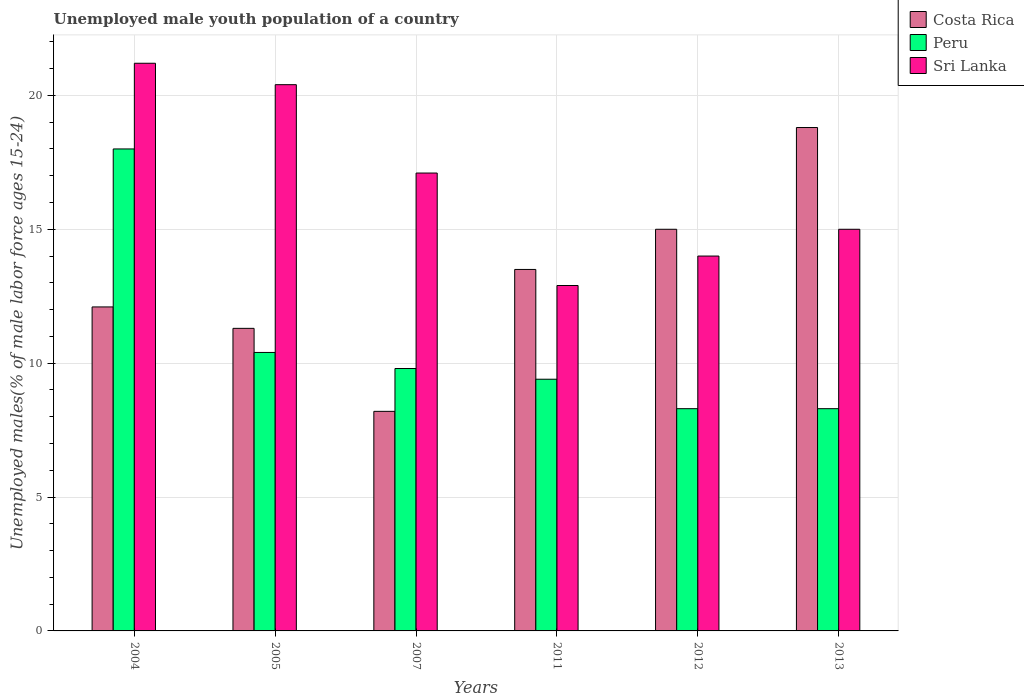How many different coloured bars are there?
Offer a very short reply. 3. How many groups of bars are there?
Your response must be concise. 6. Are the number of bars per tick equal to the number of legend labels?
Ensure brevity in your answer.  Yes. Are the number of bars on each tick of the X-axis equal?
Give a very brief answer. Yes. How many bars are there on the 1st tick from the left?
Your response must be concise. 3. In how many cases, is the number of bars for a given year not equal to the number of legend labels?
Provide a succinct answer. 0. Across all years, what is the maximum percentage of unemployed male youth population in Peru?
Ensure brevity in your answer.  18. Across all years, what is the minimum percentage of unemployed male youth population in Sri Lanka?
Your answer should be very brief. 12.9. What is the total percentage of unemployed male youth population in Costa Rica in the graph?
Offer a terse response. 78.9. What is the difference between the percentage of unemployed male youth population in Sri Lanka in 2007 and that in 2011?
Offer a terse response. 4.2. What is the difference between the percentage of unemployed male youth population in Costa Rica in 2011 and the percentage of unemployed male youth population in Sri Lanka in 2007?
Give a very brief answer. -3.6. What is the average percentage of unemployed male youth population in Peru per year?
Your response must be concise. 10.7. In the year 2013, what is the difference between the percentage of unemployed male youth population in Peru and percentage of unemployed male youth population in Costa Rica?
Your answer should be very brief. -10.5. In how many years, is the percentage of unemployed male youth population in Costa Rica greater than 1 %?
Provide a short and direct response. 6. What is the ratio of the percentage of unemployed male youth population in Sri Lanka in 2011 to that in 2013?
Offer a terse response. 0.86. Is the difference between the percentage of unemployed male youth population in Peru in 2011 and 2013 greater than the difference between the percentage of unemployed male youth population in Costa Rica in 2011 and 2013?
Provide a short and direct response. Yes. What is the difference between the highest and the second highest percentage of unemployed male youth population in Costa Rica?
Your answer should be compact. 3.8. What is the difference between the highest and the lowest percentage of unemployed male youth population in Sri Lanka?
Your response must be concise. 8.3. Is the sum of the percentage of unemployed male youth population in Sri Lanka in 2011 and 2013 greater than the maximum percentage of unemployed male youth population in Costa Rica across all years?
Provide a succinct answer. Yes. What does the 3rd bar from the right in 2005 represents?
Your answer should be very brief. Costa Rica. Is it the case that in every year, the sum of the percentage of unemployed male youth population in Costa Rica and percentage of unemployed male youth population in Sri Lanka is greater than the percentage of unemployed male youth population in Peru?
Provide a short and direct response. Yes. How many bars are there?
Provide a short and direct response. 18. Does the graph contain grids?
Ensure brevity in your answer.  Yes. What is the title of the graph?
Your answer should be compact. Unemployed male youth population of a country. Does "Central Europe" appear as one of the legend labels in the graph?
Ensure brevity in your answer.  No. What is the label or title of the Y-axis?
Your response must be concise. Unemployed males(% of male labor force ages 15-24). What is the Unemployed males(% of male labor force ages 15-24) in Costa Rica in 2004?
Provide a succinct answer. 12.1. What is the Unemployed males(% of male labor force ages 15-24) of Peru in 2004?
Provide a short and direct response. 18. What is the Unemployed males(% of male labor force ages 15-24) of Sri Lanka in 2004?
Offer a very short reply. 21.2. What is the Unemployed males(% of male labor force ages 15-24) of Costa Rica in 2005?
Keep it short and to the point. 11.3. What is the Unemployed males(% of male labor force ages 15-24) of Peru in 2005?
Your answer should be compact. 10.4. What is the Unemployed males(% of male labor force ages 15-24) of Sri Lanka in 2005?
Provide a short and direct response. 20.4. What is the Unemployed males(% of male labor force ages 15-24) of Costa Rica in 2007?
Offer a terse response. 8.2. What is the Unemployed males(% of male labor force ages 15-24) in Peru in 2007?
Your answer should be compact. 9.8. What is the Unemployed males(% of male labor force ages 15-24) of Sri Lanka in 2007?
Your answer should be very brief. 17.1. What is the Unemployed males(% of male labor force ages 15-24) of Costa Rica in 2011?
Make the answer very short. 13.5. What is the Unemployed males(% of male labor force ages 15-24) in Peru in 2011?
Provide a short and direct response. 9.4. What is the Unemployed males(% of male labor force ages 15-24) of Sri Lanka in 2011?
Give a very brief answer. 12.9. What is the Unemployed males(% of male labor force ages 15-24) in Costa Rica in 2012?
Your response must be concise. 15. What is the Unemployed males(% of male labor force ages 15-24) in Peru in 2012?
Make the answer very short. 8.3. What is the Unemployed males(% of male labor force ages 15-24) of Sri Lanka in 2012?
Your answer should be very brief. 14. What is the Unemployed males(% of male labor force ages 15-24) of Costa Rica in 2013?
Provide a succinct answer. 18.8. What is the Unemployed males(% of male labor force ages 15-24) in Peru in 2013?
Ensure brevity in your answer.  8.3. What is the Unemployed males(% of male labor force ages 15-24) of Sri Lanka in 2013?
Ensure brevity in your answer.  15. Across all years, what is the maximum Unemployed males(% of male labor force ages 15-24) in Costa Rica?
Keep it short and to the point. 18.8. Across all years, what is the maximum Unemployed males(% of male labor force ages 15-24) of Sri Lanka?
Your answer should be compact. 21.2. Across all years, what is the minimum Unemployed males(% of male labor force ages 15-24) in Costa Rica?
Offer a very short reply. 8.2. Across all years, what is the minimum Unemployed males(% of male labor force ages 15-24) in Peru?
Provide a succinct answer. 8.3. Across all years, what is the minimum Unemployed males(% of male labor force ages 15-24) in Sri Lanka?
Provide a short and direct response. 12.9. What is the total Unemployed males(% of male labor force ages 15-24) of Costa Rica in the graph?
Offer a terse response. 78.9. What is the total Unemployed males(% of male labor force ages 15-24) in Peru in the graph?
Your answer should be compact. 64.2. What is the total Unemployed males(% of male labor force ages 15-24) of Sri Lanka in the graph?
Keep it short and to the point. 100.6. What is the difference between the Unemployed males(% of male labor force ages 15-24) in Costa Rica in 2004 and that in 2005?
Provide a succinct answer. 0.8. What is the difference between the Unemployed males(% of male labor force ages 15-24) of Peru in 2004 and that in 2005?
Give a very brief answer. 7.6. What is the difference between the Unemployed males(% of male labor force ages 15-24) in Sri Lanka in 2004 and that in 2005?
Your response must be concise. 0.8. What is the difference between the Unemployed males(% of male labor force ages 15-24) of Peru in 2004 and that in 2007?
Provide a succinct answer. 8.2. What is the difference between the Unemployed males(% of male labor force ages 15-24) of Costa Rica in 2004 and that in 2011?
Provide a succinct answer. -1.4. What is the difference between the Unemployed males(% of male labor force ages 15-24) of Peru in 2004 and that in 2011?
Make the answer very short. 8.6. What is the difference between the Unemployed males(% of male labor force ages 15-24) of Sri Lanka in 2004 and that in 2011?
Offer a very short reply. 8.3. What is the difference between the Unemployed males(% of male labor force ages 15-24) of Costa Rica in 2004 and that in 2012?
Provide a short and direct response. -2.9. What is the difference between the Unemployed males(% of male labor force ages 15-24) of Peru in 2004 and that in 2012?
Make the answer very short. 9.7. What is the difference between the Unemployed males(% of male labor force ages 15-24) of Sri Lanka in 2004 and that in 2013?
Your response must be concise. 6.2. What is the difference between the Unemployed males(% of male labor force ages 15-24) of Costa Rica in 2005 and that in 2007?
Make the answer very short. 3.1. What is the difference between the Unemployed males(% of male labor force ages 15-24) of Peru in 2005 and that in 2007?
Give a very brief answer. 0.6. What is the difference between the Unemployed males(% of male labor force ages 15-24) in Costa Rica in 2005 and that in 2011?
Provide a succinct answer. -2.2. What is the difference between the Unemployed males(% of male labor force ages 15-24) of Sri Lanka in 2005 and that in 2012?
Your response must be concise. 6.4. What is the difference between the Unemployed males(% of male labor force ages 15-24) of Costa Rica in 2005 and that in 2013?
Your answer should be compact. -7.5. What is the difference between the Unemployed males(% of male labor force ages 15-24) of Sri Lanka in 2007 and that in 2011?
Your answer should be compact. 4.2. What is the difference between the Unemployed males(% of male labor force ages 15-24) in Costa Rica in 2007 and that in 2012?
Keep it short and to the point. -6.8. What is the difference between the Unemployed males(% of male labor force ages 15-24) in Costa Rica in 2007 and that in 2013?
Offer a terse response. -10.6. What is the difference between the Unemployed males(% of male labor force ages 15-24) in Sri Lanka in 2007 and that in 2013?
Ensure brevity in your answer.  2.1. What is the difference between the Unemployed males(% of male labor force ages 15-24) of Costa Rica in 2011 and that in 2012?
Provide a succinct answer. -1.5. What is the difference between the Unemployed males(% of male labor force ages 15-24) of Peru in 2011 and that in 2012?
Make the answer very short. 1.1. What is the difference between the Unemployed males(% of male labor force ages 15-24) in Peru in 2011 and that in 2013?
Make the answer very short. 1.1. What is the difference between the Unemployed males(% of male labor force ages 15-24) in Sri Lanka in 2012 and that in 2013?
Ensure brevity in your answer.  -1. What is the difference between the Unemployed males(% of male labor force ages 15-24) in Costa Rica in 2004 and the Unemployed males(% of male labor force ages 15-24) in Sri Lanka in 2005?
Your answer should be compact. -8.3. What is the difference between the Unemployed males(% of male labor force ages 15-24) of Costa Rica in 2004 and the Unemployed males(% of male labor force ages 15-24) of Peru in 2007?
Your answer should be very brief. 2.3. What is the difference between the Unemployed males(% of male labor force ages 15-24) of Costa Rica in 2004 and the Unemployed males(% of male labor force ages 15-24) of Sri Lanka in 2007?
Offer a terse response. -5. What is the difference between the Unemployed males(% of male labor force ages 15-24) of Peru in 2004 and the Unemployed males(% of male labor force ages 15-24) of Sri Lanka in 2007?
Give a very brief answer. 0.9. What is the difference between the Unemployed males(% of male labor force ages 15-24) of Costa Rica in 2004 and the Unemployed males(% of male labor force ages 15-24) of Sri Lanka in 2012?
Make the answer very short. -1.9. What is the difference between the Unemployed males(% of male labor force ages 15-24) of Peru in 2004 and the Unemployed males(% of male labor force ages 15-24) of Sri Lanka in 2012?
Offer a terse response. 4. What is the difference between the Unemployed males(% of male labor force ages 15-24) of Peru in 2004 and the Unemployed males(% of male labor force ages 15-24) of Sri Lanka in 2013?
Your response must be concise. 3. What is the difference between the Unemployed males(% of male labor force ages 15-24) in Costa Rica in 2005 and the Unemployed males(% of male labor force ages 15-24) in Sri Lanka in 2007?
Your answer should be very brief. -5.8. What is the difference between the Unemployed males(% of male labor force ages 15-24) in Peru in 2005 and the Unemployed males(% of male labor force ages 15-24) in Sri Lanka in 2007?
Provide a succinct answer. -6.7. What is the difference between the Unemployed males(% of male labor force ages 15-24) of Costa Rica in 2005 and the Unemployed males(% of male labor force ages 15-24) of Peru in 2011?
Offer a terse response. 1.9. What is the difference between the Unemployed males(% of male labor force ages 15-24) in Costa Rica in 2005 and the Unemployed males(% of male labor force ages 15-24) in Sri Lanka in 2011?
Provide a succinct answer. -1.6. What is the difference between the Unemployed males(% of male labor force ages 15-24) of Peru in 2005 and the Unemployed males(% of male labor force ages 15-24) of Sri Lanka in 2011?
Your response must be concise. -2.5. What is the difference between the Unemployed males(% of male labor force ages 15-24) in Costa Rica in 2005 and the Unemployed males(% of male labor force ages 15-24) in Sri Lanka in 2012?
Your answer should be very brief. -2.7. What is the difference between the Unemployed males(% of male labor force ages 15-24) in Costa Rica in 2007 and the Unemployed males(% of male labor force ages 15-24) in Peru in 2011?
Your answer should be compact. -1.2. What is the difference between the Unemployed males(% of male labor force ages 15-24) of Peru in 2007 and the Unemployed males(% of male labor force ages 15-24) of Sri Lanka in 2012?
Provide a succinct answer. -4.2. What is the difference between the Unemployed males(% of male labor force ages 15-24) in Costa Rica in 2007 and the Unemployed males(% of male labor force ages 15-24) in Peru in 2013?
Your answer should be very brief. -0.1. What is the difference between the Unemployed males(% of male labor force ages 15-24) of Peru in 2007 and the Unemployed males(% of male labor force ages 15-24) of Sri Lanka in 2013?
Offer a terse response. -5.2. What is the difference between the Unemployed males(% of male labor force ages 15-24) of Costa Rica in 2011 and the Unemployed males(% of male labor force ages 15-24) of Peru in 2012?
Your answer should be very brief. 5.2. What is the difference between the Unemployed males(% of male labor force ages 15-24) of Costa Rica in 2011 and the Unemployed males(% of male labor force ages 15-24) of Peru in 2013?
Your response must be concise. 5.2. What is the difference between the Unemployed males(% of male labor force ages 15-24) in Costa Rica in 2011 and the Unemployed males(% of male labor force ages 15-24) in Sri Lanka in 2013?
Your answer should be compact. -1.5. What is the difference between the Unemployed males(% of male labor force ages 15-24) in Peru in 2011 and the Unemployed males(% of male labor force ages 15-24) in Sri Lanka in 2013?
Provide a succinct answer. -5.6. What is the difference between the Unemployed males(% of male labor force ages 15-24) in Costa Rica in 2012 and the Unemployed males(% of male labor force ages 15-24) in Sri Lanka in 2013?
Provide a short and direct response. 0. What is the average Unemployed males(% of male labor force ages 15-24) of Costa Rica per year?
Provide a succinct answer. 13.15. What is the average Unemployed males(% of male labor force ages 15-24) of Peru per year?
Give a very brief answer. 10.7. What is the average Unemployed males(% of male labor force ages 15-24) in Sri Lanka per year?
Provide a short and direct response. 16.77. In the year 2004, what is the difference between the Unemployed males(% of male labor force ages 15-24) in Costa Rica and Unemployed males(% of male labor force ages 15-24) in Peru?
Your answer should be compact. -5.9. In the year 2004, what is the difference between the Unemployed males(% of male labor force ages 15-24) in Costa Rica and Unemployed males(% of male labor force ages 15-24) in Sri Lanka?
Offer a terse response. -9.1. In the year 2005, what is the difference between the Unemployed males(% of male labor force ages 15-24) in Costa Rica and Unemployed males(% of male labor force ages 15-24) in Sri Lanka?
Offer a very short reply. -9.1. In the year 2005, what is the difference between the Unemployed males(% of male labor force ages 15-24) of Peru and Unemployed males(% of male labor force ages 15-24) of Sri Lanka?
Give a very brief answer. -10. In the year 2007, what is the difference between the Unemployed males(% of male labor force ages 15-24) in Peru and Unemployed males(% of male labor force ages 15-24) in Sri Lanka?
Your answer should be compact. -7.3. In the year 2011, what is the difference between the Unemployed males(% of male labor force ages 15-24) in Costa Rica and Unemployed males(% of male labor force ages 15-24) in Peru?
Offer a very short reply. 4.1. In the year 2012, what is the difference between the Unemployed males(% of male labor force ages 15-24) of Costa Rica and Unemployed males(% of male labor force ages 15-24) of Sri Lanka?
Make the answer very short. 1. In the year 2013, what is the difference between the Unemployed males(% of male labor force ages 15-24) of Peru and Unemployed males(% of male labor force ages 15-24) of Sri Lanka?
Provide a short and direct response. -6.7. What is the ratio of the Unemployed males(% of male labor force ages 15-24) in Costa Rica in 2004 to that in 2005?
Provide a succinct answer. 1.07. What is the ratio of the Unemployed males(% of male labor force ages 15-24) in Peru in 2004 to that in 2005?
Make the answer very short. 1.73. What is the ratio of the Unemployed males(% of male labor force ages 15-24) of Sri Lanka in 2004 to that in 2005?
Provide a succinct answer. 1.04. What is the ratio of the Unemployed males(% of male labor force ages 15-24) of Costa Rica in 2004 to that in 2007?
Your response must be concise. 1.48. What is the ratio of the Unemployed males(% of male labor force ages 15-24) in Peru in 2004 to that in 2007?
Ensure brevity in your answer.  1.84. What is the ratio of the Unemployed males(% of male labor force ages 15-24) of Sri Lanka in 2004 to that in 2007?
Your response must be concise. 1.24. What is the ratio of the Unemployed males(% of male labor force ages 15-24) of Costa Rica in 2004 to that in 2011?
Keep it short and to the point. 0.9. What is the ratio of the Unemployed males(% of male labor force ages 15-24) in Peru in 2004 to that in 2011?
Make the answer very short. 1.91. What is the ratio of the Unemployed males(% of male labor force ages 15-24) of Sri Lanka in 2004 to that in 2011?
Make the answer very short. 1.64. What is the ratio of the Unemployed males(% of male labor force ages 15-24) of Costa Rica in 2004 to that in 2012?
Your answer should be compact. 0.81. What is the ratio of the Unemployed males(% of male labor force ages 15-24) of Peru in 2004 to that in 2012?
Your answer should be very brief. 2.17. What is the ratio of the Unemployed males(% of male labor force ages 15-24) of Sri Lanka in 2004 to that in 2012?
Ensure brevity in your answer.  1.51. What is the ratio of the Unemployed males(% of male labor force ages 15-24) of Costa Rica in 2004 to that in 2013?
Give a very brief answer. 0.64. What is the ratio of the Unemployed males(% of male labor force ages 15-24) of Peru in 2004 to that in 2013?
Give a very brief answer. 2.17. What is the ratio of the Unemployed males(% of male labor force ages 15-24) in Sri Lanka in 2004 to that in 2013?
Offer a terse response. 1.41. What is the ratio of the Unemployed males(% of male labor force ages 15-24) of Costa Rica in 2005 to that in 2007?
Your answer should be compact. 1.38. What is the ratio of the Unemployed males(% of male labor force ages 15-24) in Peru in 2005 to that in 2007?
Offer a terse response. 1.06. What is the ratio of the Unemployed males(% of male labor force ages 15-24) of Sri Lanka in 2005 to that in 2007?
Keep it short and to the point. 1.19. What is the ratio of the Unemployed males(% of male labor force ages 15-24) of Costa Rica in 2005 to that in 2011?
Ensure brevity in your answer.  0.84. What is the ratio of the Unemployed males(% of male labor force ages 15-24) in Peru in 2005 to that in 2011?
Offer a very short reply. 1.11. What is the ratio of the Unemployed males(% of male labor force ages 15-24) in Sri Lanka in 2005 to that in 2011?
Your answer should be compact. 1.58. What is the ratio of the Unemployed males(% of male labor force ages 15-24) of Costa Rica in 2005 to that in 2012?
Provide a short and direct response. 0.75. What is the ratio of the Unemployed males(% of male labor force ages 15-24) in Peru in 2005 to that in 2012?
Make the answer very short. 1.25. What is the ratio of the Unemployed males(% of male labor force ages 15-24) of Sri Lanka in 2005 to that in 2012?
Provide a short and direct response. 1.46. What is the ratio of the Unemployed males(% of male labor force ages 15-24) of Costa Rica in 2005 to that in 2013?
Ensure brevity in your answer.  0.6. What is the ratio of the Unemployed males(% of male labor force ages 15-24) in Peru in 2005 to that in 2013?
Provide a short and direct response. 1.25. What is the ratio of the Unemployed males(% of male labor force ages 15-24) in Sri Lanka in 2005 to that in 2013?
Make the answer very short. 1.36. What is the ratio of the Unemployed males(% of male labor force ages 15-24) of Costa Rica in 2007 to that in 2011?
Make the answer very short. 0.61. What is the ratio of the Unemployed males(% of male labor force ages 15-24) of Peru in 2007 to that in 2011?
Offer a very short reply. 1.04. What is the ratio of the Unemployed males(% of male labor force ages 15-24) in Sri Lanka in 2007 to that in 2011?
Provide a succinct answer. 1.33. What is the ratio of the Unemployed males(% of male labor force ages 15-24) of Costa Rica in 2007 to that in 2012?
Your answer should be compact. 0.55. What is the ratio of the Unemployed males(% of male labor force ages 15-24) in Peru in 2007 to that in 2012?
Your answer should be compact. 1.18. What is the ratio of the Unemployed males(% of male labor force ages 15-24) of Sri Lanka in 2007 to that in 2012?
Ensure brevity in your answer.  1.22. What is the ratio of the Unemployed males(% of male labor force ages 15-24) in Costa Rica in 2007 to that in 2013?
Offer a terse response. 0.44. What is the ratio of the Unemployed males(% of male labor force ages 15-24) of Peru in 2007 to that in 2013?
Keep it short and to the point. 1.18. What is the ratio of the Unemployed males(% of male labor force ages 15-24) in Sri Lanka in 2007 to that in 2013?
Ensure brevity in your answer.  1.14. What is the ratio of the Unemployed males(% of male labor force ages 15-24) in Peru in 2011 to that in 2012?
Give a very brief answer. 1.13. What is the ratio of the Unemployed males(% of male labor force ages 15-24) of Sri Lanka in 2011 to that in 2012?
Provide a short and direct response. 0.92. What is the ratio of the Unemployed males(% of male labor force ages 15-24) in Costa Rica in 2011 to that in 2013?
Offer a terse response. 0.72. What is the ratio of the Unemployed males(% of male labor force ages 15-24) in Peru in 2011 to that in 2013?
Keep it short and to the point. 1.13. What is the ratio of the Unemployed males(% of male labor force ages 15-24) of Sri Lanka in 2011 to that in 2013?
Provide a succinct answer. 0.86. What is the ratio of the Unemployed males(% of male labor force ages 15-24) in Costa Rica in 2012 to that in 2013?
Keep it short and to the point. 0.8. What is the ratio of the Unemployed males(% of male labor force ages 15-24) in Peru in 2012 to that in 2013?
Offer a terse response. 1. What is the difference between the highest and the second highest Unemployed males(% of male labor force ages 15-24) in Costa Rica?
Provide a succinct answer. 3.8. What is the difference between the highest and the second highest Unemployed males(% of male labor force ages 15-24) in Peru?
Keep it short and to the point. 7.6. What is the difference between the highest and the second highest Unemployed males(% of male labor force ages 15-24) of Sri Lanka?
Your answer should be very brief. 0.8. What is the difference between the highest and the lowest Unemployed males(% of male labor force ages 15-24) in Peru?
Offer a terse response. 9.7. 